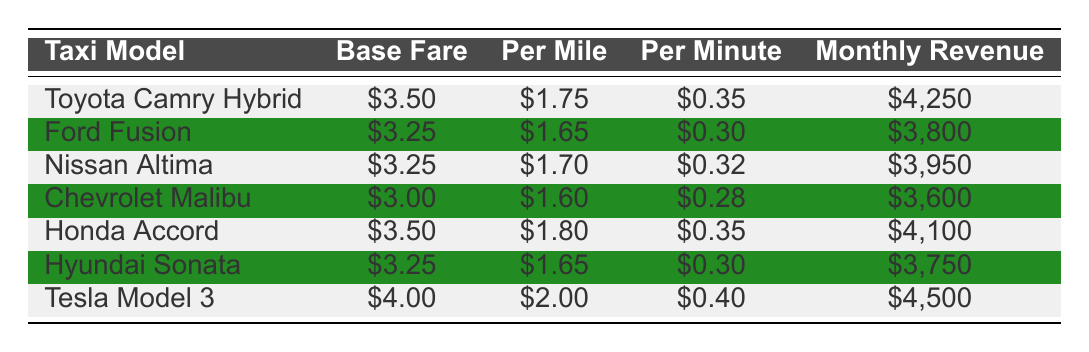What is the monthly revenue for the Ford Fusion? The Ford Fusion's monthly revenue is listed directly in the table under the "Monthly Revenue" column. It shows $3,800.
Answer: $3,800 Which taxi model has the highest monthly revenue? By comparing the "Monthly Revenue" column from all the taxi models, the Tesla Model 3 shows the highest revenue of $4,500.
Answer: Tesla Model 3 How much more revenue does the Toyota Camry Hybrid generate compared to the Chevrolet Malibu? The monthly revenue for the Toyota Camry Hybrid is $4,250 and for the Chevrolet Malibu is $3,600. The difference is calculated by subtracting: $4,250 - $3,600 = $650.
Answer: $650 Is the base fare of the Nissan Altima higher than that of the Honda Accord? The base fare for the Nissan Altima is $3.25, while for the Honda Accord it is $3.50. Since $3.25 is less than $3.50, the statement is false.
Answer: No What is the average monthly revenue of the taxi models that have a base fare of $3.25? The taxi models with a base fare of $3.25 are the Ford Fusion and the Hyundai Sonata. Their monthly revenues are $3,800 and $3,750, respectively. To find the average, first sum these values: $3,800 + $3,750 = $7,550. Then divide by the number of models (2): $7,550 / 2 = $3,775.
Answer: $3,775 Which taxi model has the lowest per mile charge, and what is that charge? By examining the "Per Mile" column, the Chevrolet Malibu has the lowest charge of $1.60, the lowest compared to the other models.
Answer: Chevrolet Malibu, $1.60 Is the monthly revenue of the Tesla Model 3 at least $4,000? The monthly revenue for the Tesla Model 3 is $4,500. Since $4,500 is greater than $4,000, the statement is true.
Answer: Yes How much total revenue is generated by all taxi models combined? By adding the monthly revenues of all the taxi models: $4,250 (Toyota Camry Hybrid) + $3,800 (Ford Fusion) + $3,950 (Nissan Altima) + $3,600 (Chevrolet Malibu) + $4,100 (Honda Accord) + $3,750 (Hyundai Sonata) + $4,500 (Tesla Model 3), the total is $27,950.
Answer: $27,950 